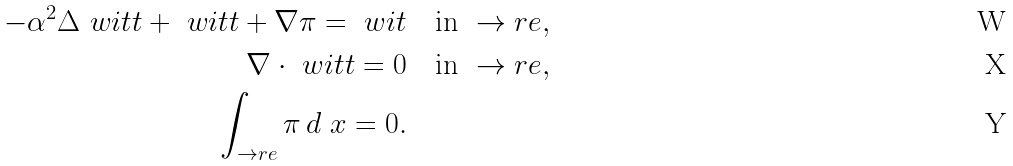Convert formula to latex. <formula><loc_0><loc_0><loc_500><loc_500>- \alpha ^ { 2 } \Delta \ w i t t + \ w i t t + \nabla \pi = \ w i t & \quad \text {in } \to r e , \\ \nabla \cdot \ w i t t = 0 & \quad \text {in } \to r e , \\ \int _ { \to r e } \pi \, d \ x = 0 .</formula> 